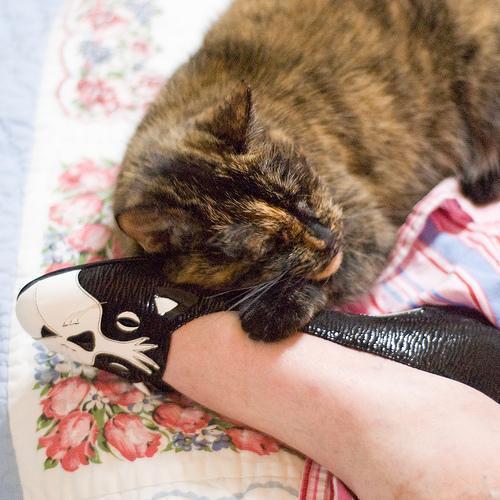How many shoes are in the picture?
Give a very brief answer. 1. 